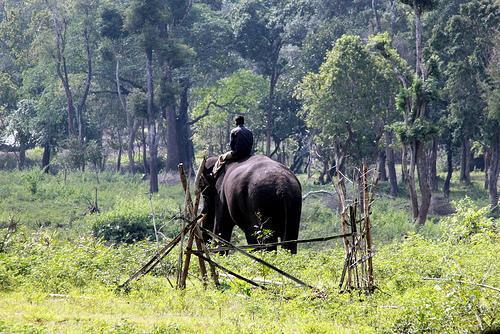How many elephants are in the picture?
Give a very brief answer. 1. 